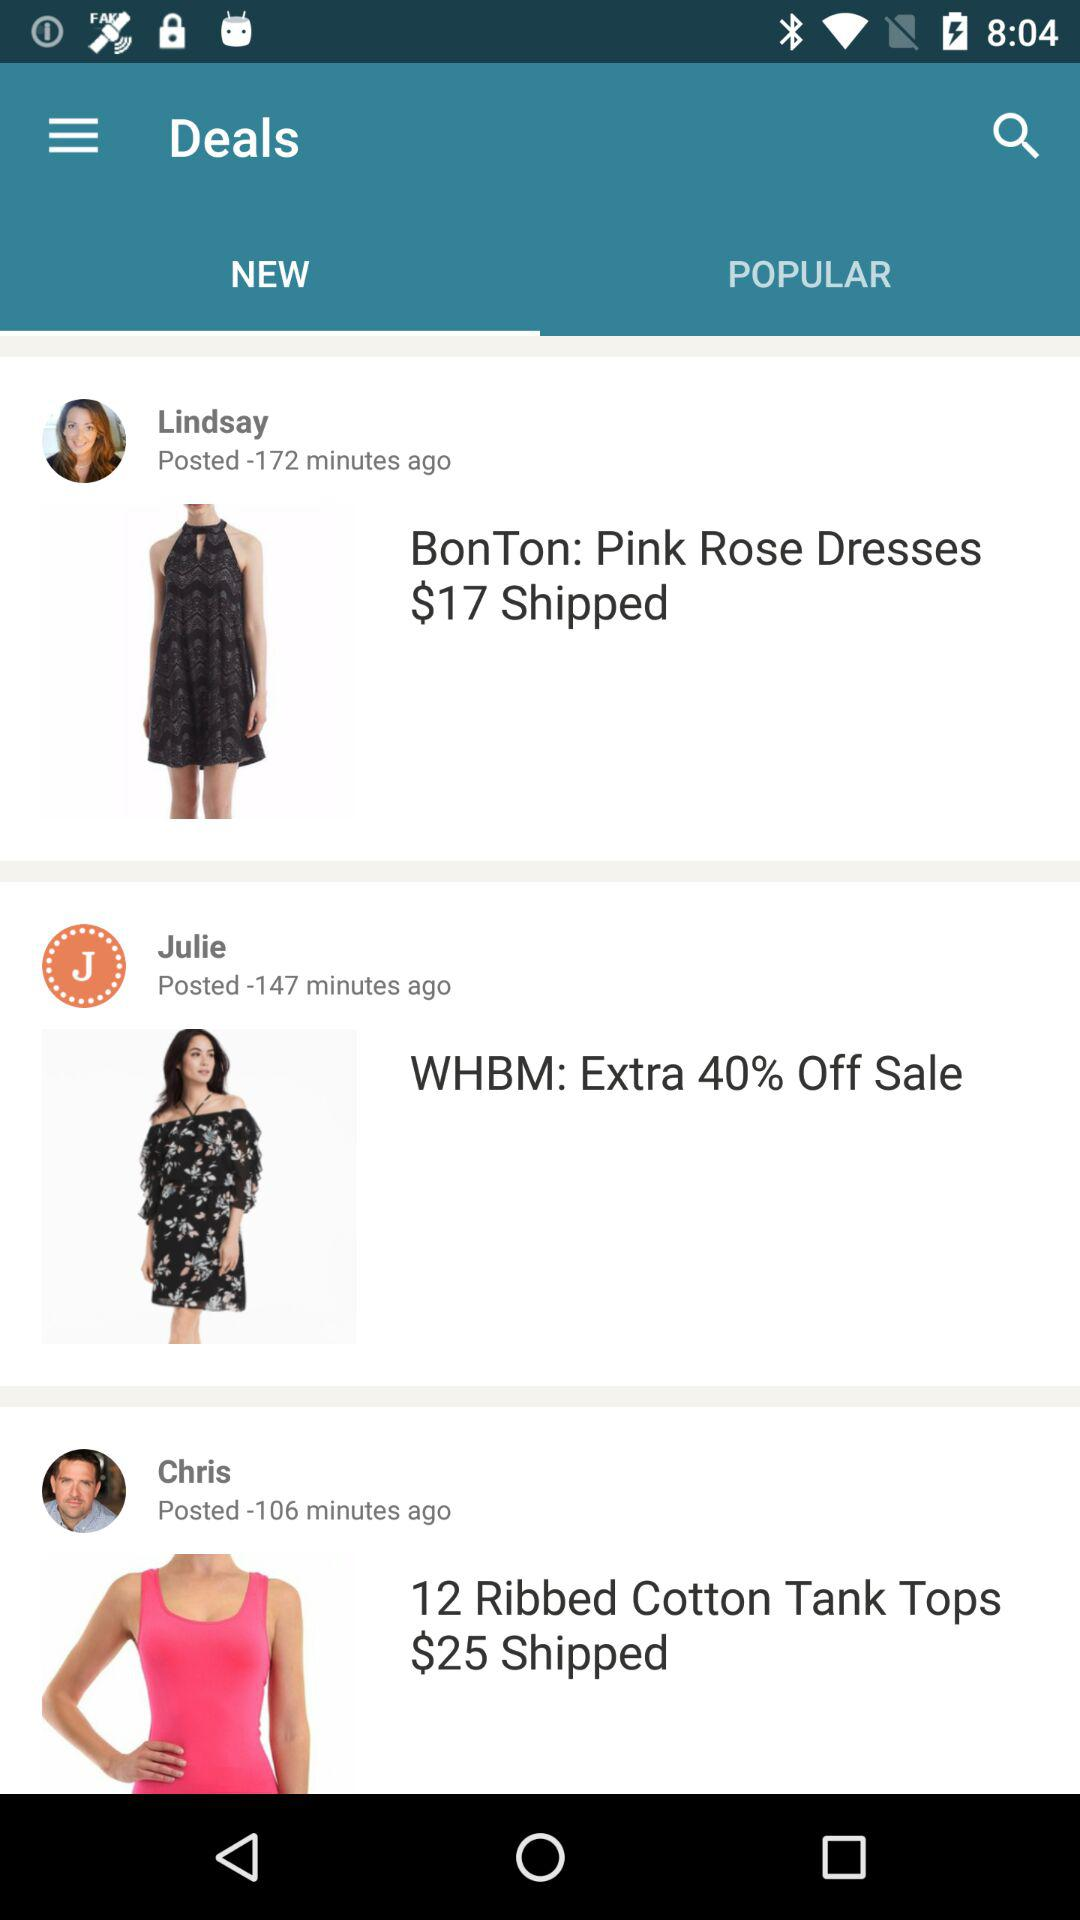What is the price of "BonTon: Pink Rose Dresses"? The price is $17. 